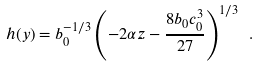Convert formula to latex. <formula><loc_0><loc_0><loc_500><loc_500>h ( y ) = b _ { 0 } ^ { - 1 / 3 } \left ( - 2 \alpha z - \frac { 8 b _ { 0 } c _ { 0 } ^ { 3 } } { 2 7 } \right ) ^ { 1 / 3 } \ .</formula> 